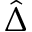<formula> <loc_0><loc_0><loc_500><loc_500>\hat { \Delta }</formula> 